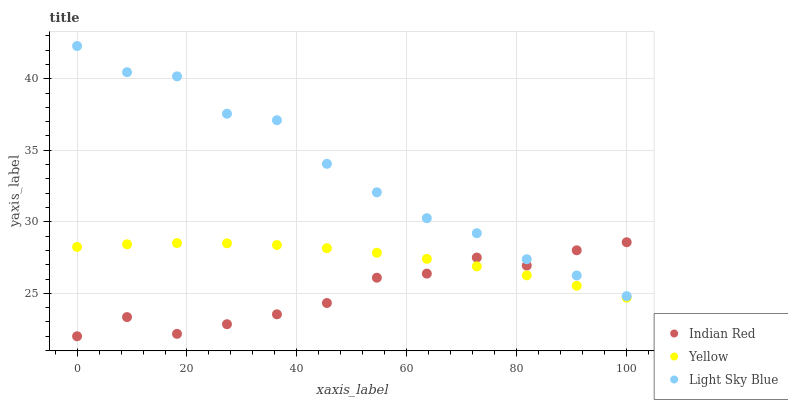Does Indian Red have the minimum area under the curve?
Answer yes or no. Yes. Does Light Sky Blue have the maximum area under the curve?
Answer yes or no. Yes. Does Yellow have the minimum area under the curve?
Answer yes or no. No. Does Yellow have the maximum area under the curve?
Answer yes or no. No. Is Yellow the smoothest?
Answer yes or no. Yes. Is Light Sky Blue the roughest?
Answer yes or no. Yes. Is Indian Red the smoothest?
Answer yes or no. No. Is Indian Red the roughest?
Answer yes or no. No. Does Indian Red have the lowest value?
Answer yes or no. Yes. Does Yellow have the lowest value?
Answer yes or no. No. Does Light Sky Blue have the highest value?
Answer yes or no. Yes. Does Indian Red have the highest value?
Answer yes or no. No. Is Yellow less than Light Sky Blue?
Answer yes or no. Yes. Is Light Sky Blue greater than Yellow?
Answer yes or no. Yes. Does Indian Red intersect Light Sky Blue?
Answer yes or no. Yes. Is Indian Red less than Light Sky Blue?
Answer yes or no. No. Is Indian Red greater than Light Sky Blue?
Answer yes or no. No. Does Yellow intersect Light Sky Blue?
Answer yes or no. No. 